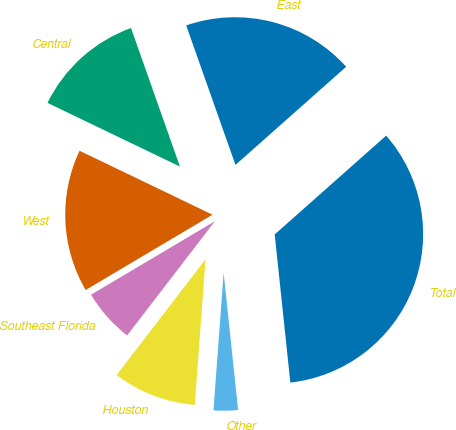<chart> <loc_0><loc_0><loc_500><loc_500><pie_chart><fcel>East<fcel>Central<fcel>West<fcel>Southeast Florida<fcel>Houston<fcel>Other<fcel>Total<nl><fcel>18.86%<fcel>12.46%<fcel>15.66%<fcel>6.05%<fcel>9.25%<fcel>2.85%<fcel>34.87%<nl></chart> 